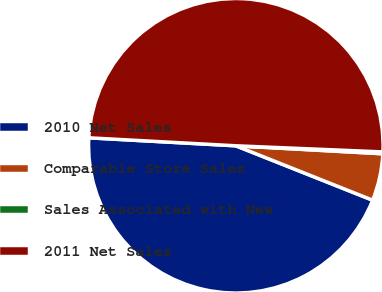Convert chart. <chart><loc_0><loc_0><loc_500><loc_500><pie_chart><fcel>2010 Net Sales<fcel>Comparable Store Sales<fcel>Sales Associated with New<fcel>2011 Net Sales<nl><fcel>44.84%<fcel>5.16%<fcel>0.2%<fcel>49.8%<nl></chart> 